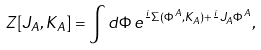Convert formula to latex. <formula><loc_0><loc_0><loc_500><loc_500>Z [ J _ { A } , K _ { A } ] = \int d \Phi \, e ^ { { \frac { i } { } } \Sigma ( \Phi ^ { A } , K _ { A } ) + { \frac { i } { } } J _ { A } \Phi ^ { A } } ,</formula> 